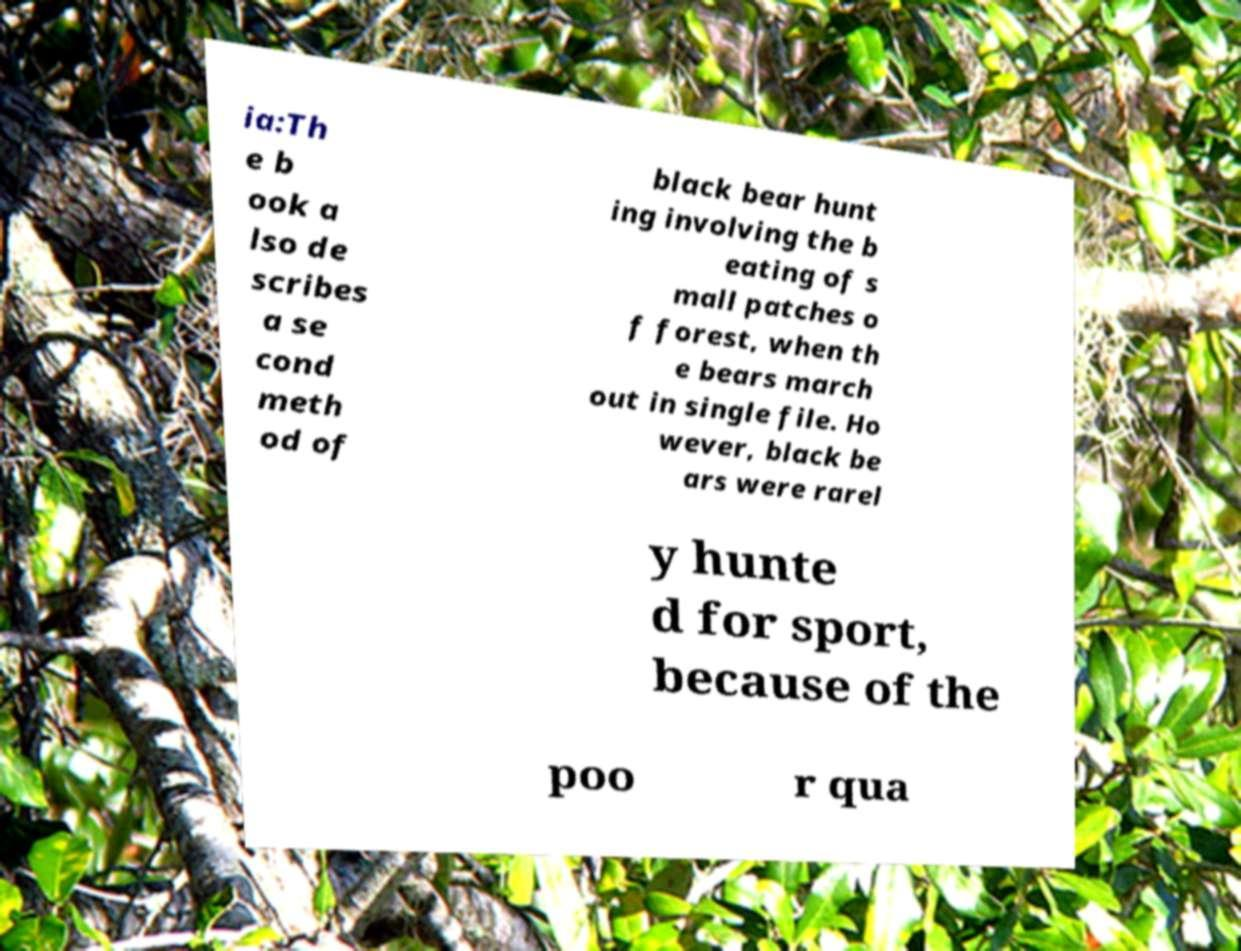I need the written content from this picture converted into text. Can you do that? ia:Th e b ook a lso de scribes a se cond meth od of black bear hunt ing involving the b eating of s mall patches o f forest, when th e bears march out in single file. Ho wever, black be ars were rarel y hunte d for sport, because of the poo r qua 